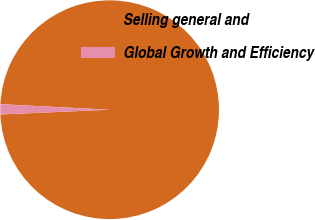Convert chart to OTSL. <chart><loc_0><loc_0><loc_500><loc_500><pie_chart><fcel>Selling general and<fcel>Global Growth and Efficiency<nl><fcel>98.5%<fcel>1.5%<nl></chart> 